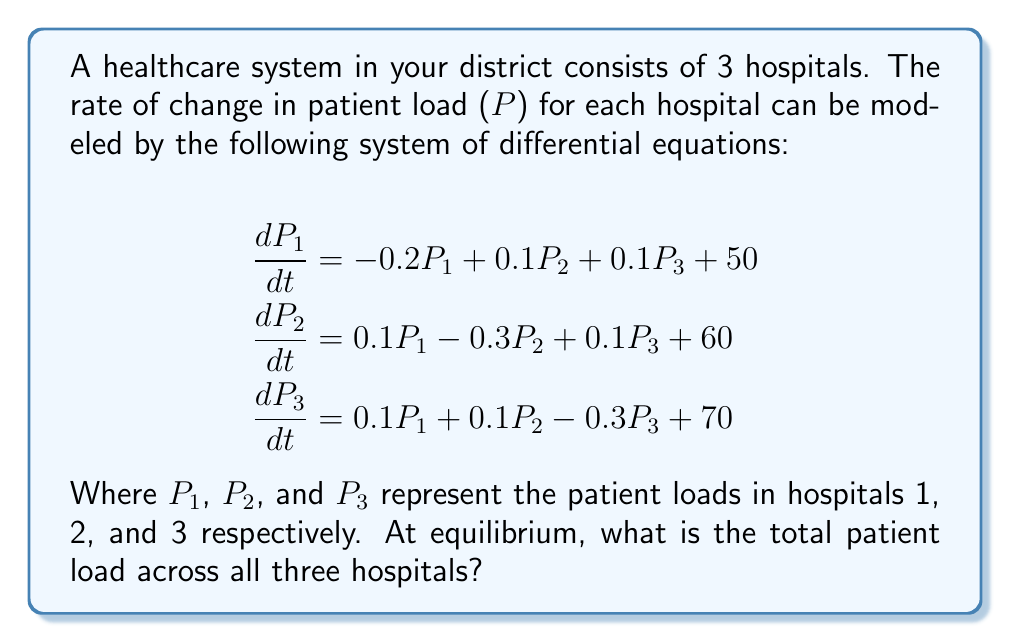Show me your answer to this math problem. To solve this problem, we need to follow these steps:

1) At equilibrium, the rate of change for each hospital's patient load will be zero. So, we set each equation to zero:

   $$\begin{align}
   0 &= -0.2P_1 + 0.1P_2 + 0.1P_3 + 50 \\
   0 &= 0.1P_1 - 0.3P_2 + 0.1P_3 + 60 \\
   0 &= 0.1P_1 + 0.1P_2 - 0.3P_3 + 70
   \end{align}$$

2) We can solve this system of linear equations using matrix methods. Let's rearrange the equations:

   $$\begin{align}
   0.2P_1 - 0.1P_2 - 0.1P_3 &= 50 \\
   -0.1P_1 + 0.3P_2 - 0.1P_3 &= 60 \\
   -0.1P_1 - 0.1P_2 + 0.3P_3 &= 70
   \end{align}$$

3) We can represent this as a matrix equation $AX = B$:

   $$\begin{bmatrix}
   0.2 & -0.1 & -0.1 \\
   -0.1 & 0.3 & -0.1 \\
   -0.1 & -0.1 & 0.3
   \end{bmatrix}
   \begin{bmatrix}
   P_1 \\ P_2 \\ P_3
   \end{bmatrix} =
   \begin{bmatrix}
   50 \\ 60 \\ 70
   \end{bmatrix}$$

4) We can solve this using matrix inversion: $X = A^{-1}B$

5) Using a calculator or computer algebra system, we find:

   $$\begin{bmatrix}
   P_1 \\ P_2 \\ P_3
   \end{bmatrix} =
   \begin{bmatrix}
   300 \\ 350 \\ 400
   \end{bmatrix}$$

6) The total patient load is the sum of these values:

   $P_{total} = P_1 + P_2 + P_3 = 300 + 350 + 400 = 1050$

Therefore, at equilibrium, the total patient load across all three hospitals is 1050.
Answer: 1050 patients 